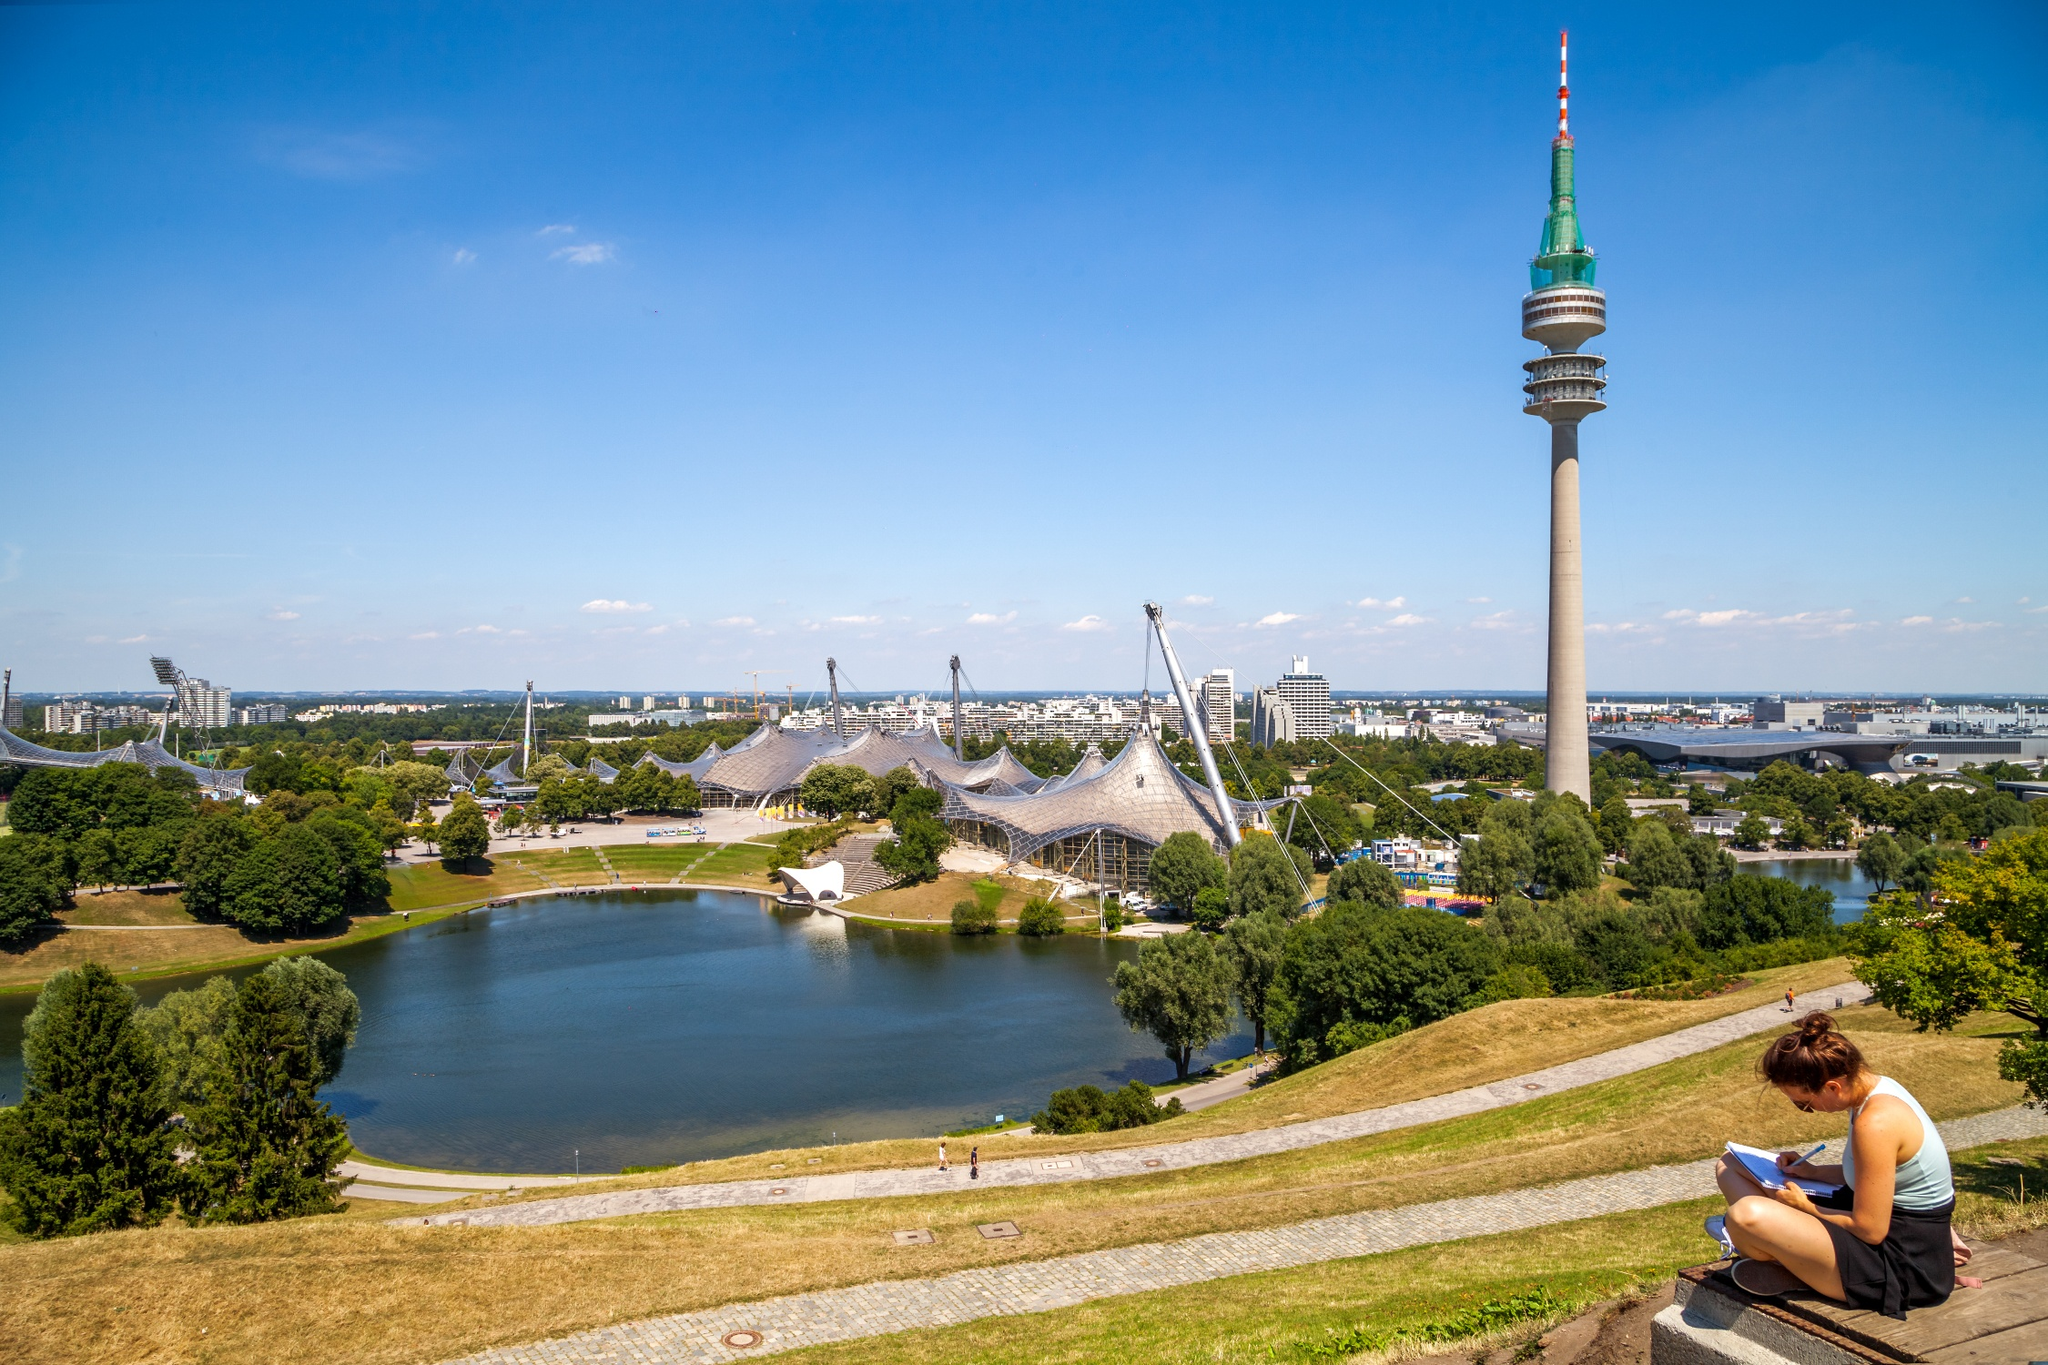If this park could speak, what story would it tell about its favorite day? If the Olympic Park could speak, it would recount the pride and joy of the day it hosted the 1972 Summer Olympics opening ceremony. The park would remember the hustle and bustle of athletes from around the world, the cheer of thousands of spectators, and the warmth of the Olympic flame as it ignited the cauldron, a symbol of unity and peace. It would reminisce about the vibrant energy, the historic moments etched into its grounds, and the spirit of international camaraderie that filled the air. This day encapsulated the essence of the park's purpose, bringing together people from all corners of the globe in a celebration of sport, culture, and friendship. 